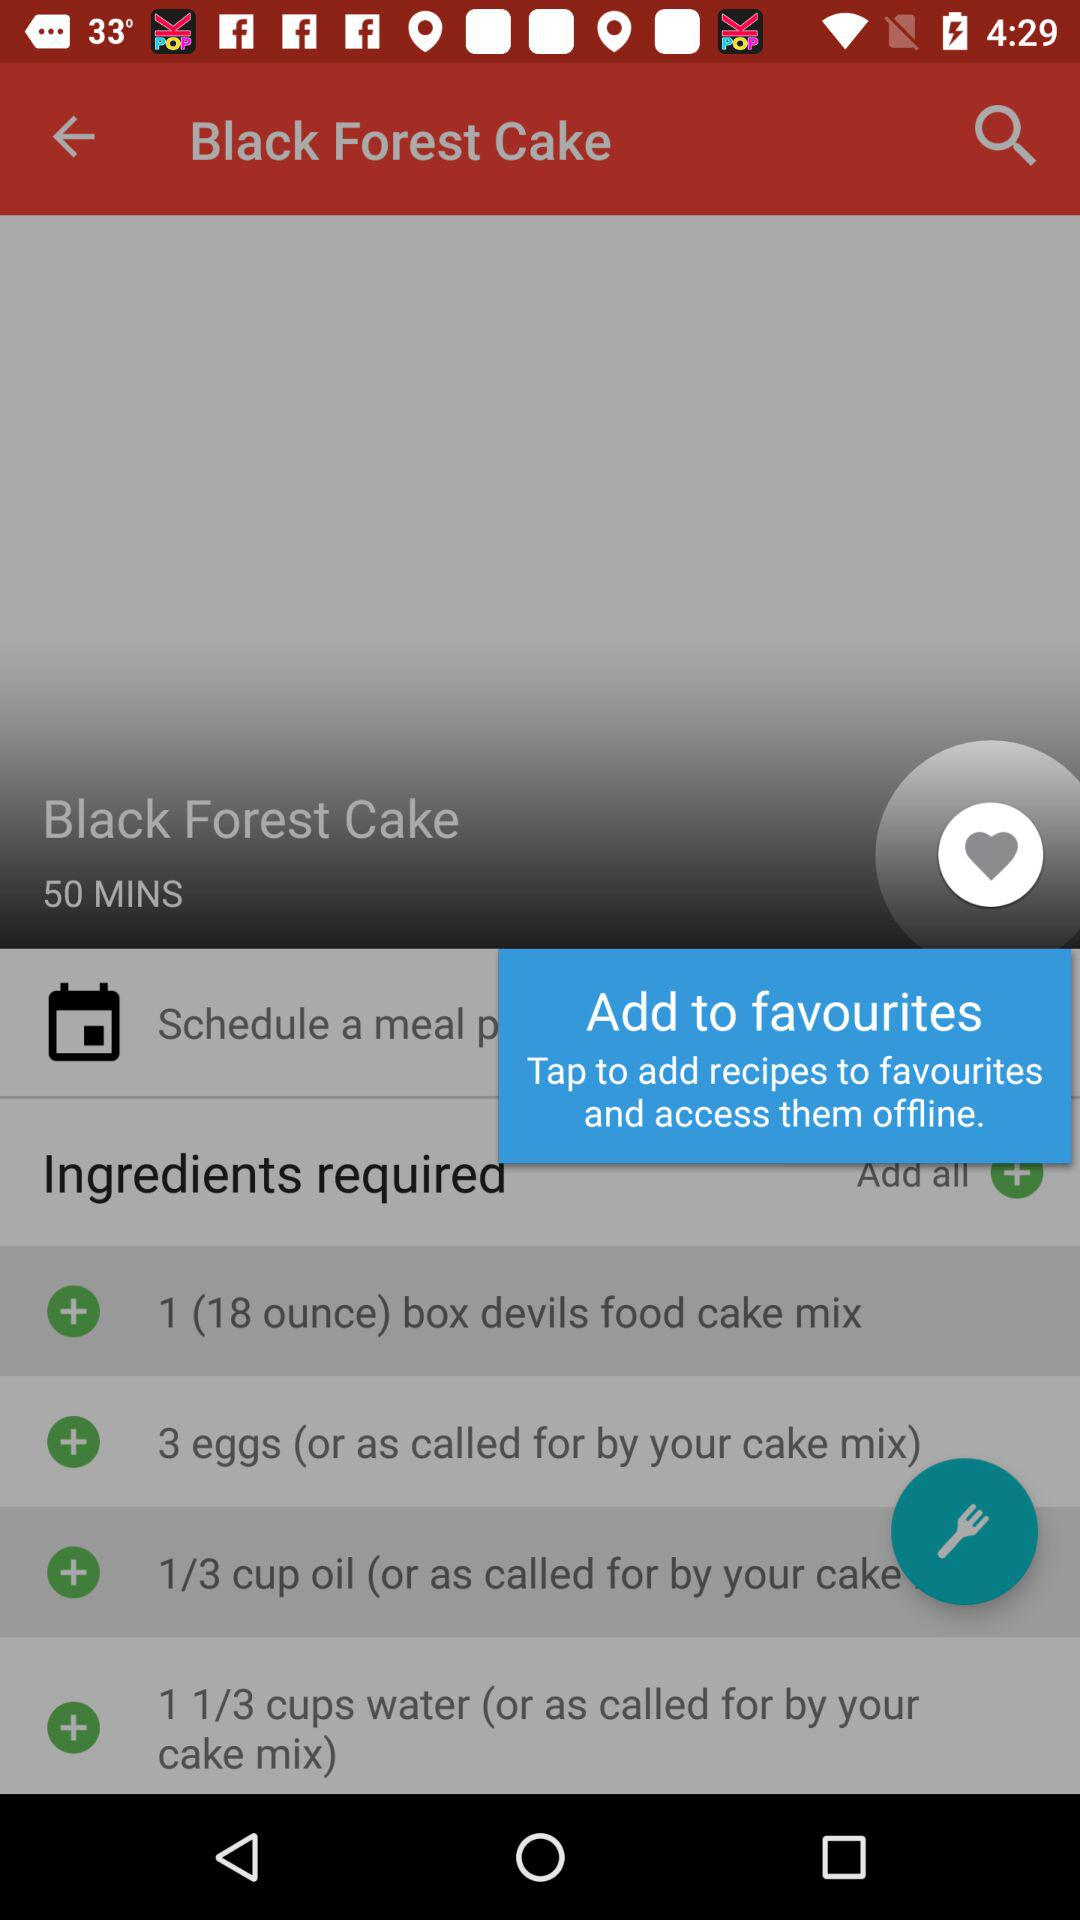What is the name of the dish? The name of the dish is "Black Forest Cake". 